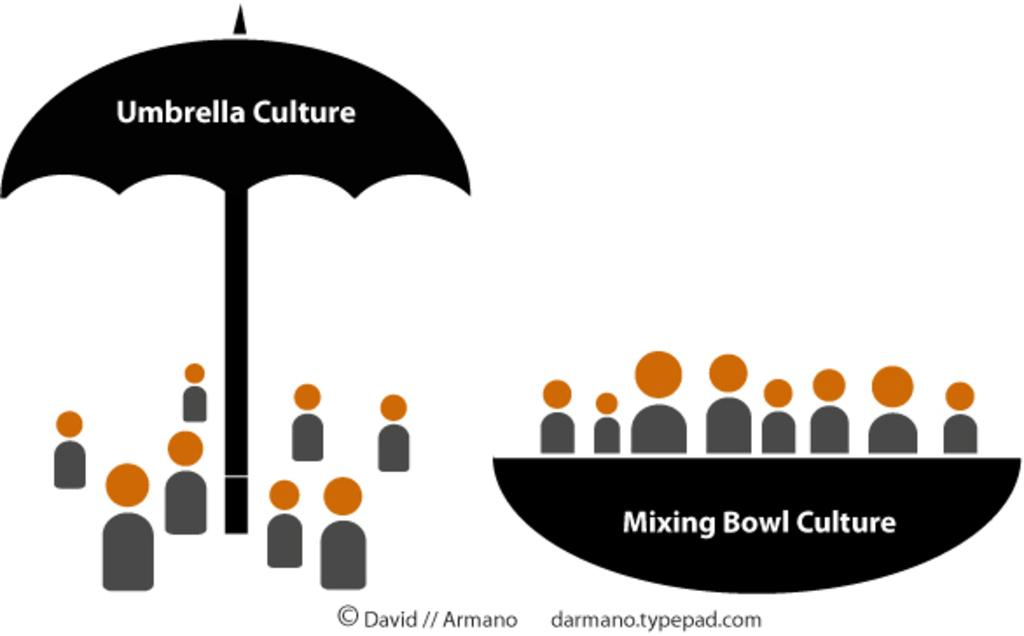What is the main subject of the poster in the image? The poster contains an image of an umbrella and a bowl. What else can be seen on the poster besides the images? There is text or writing on the poster. What type of jam is being advertised on the poster? There is no jam being advertised on the poster; it contains images of an umbrella and a bowl, along with text or writing. 